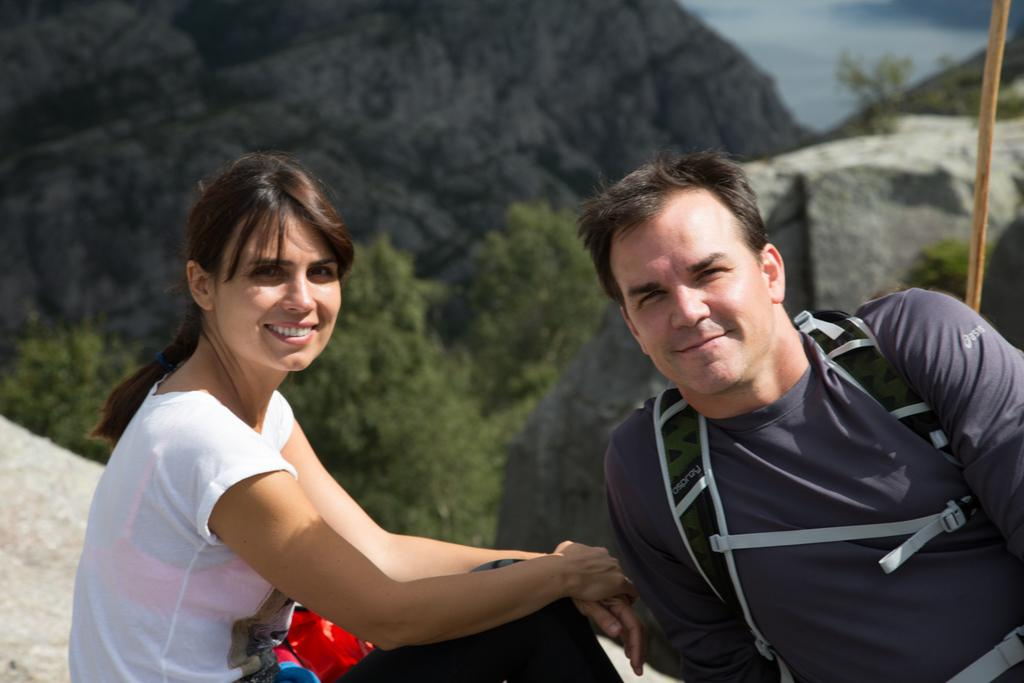What can be seen in the image related to people? There are persons wearing clothes in the image. What type of natural elements are present in the image? There are trees and hills in the image. What type of cellar can be seen in the image? There is no cellar present in the image. What type of trade is being conducted in the image? There is no trade being conducted in the image. 